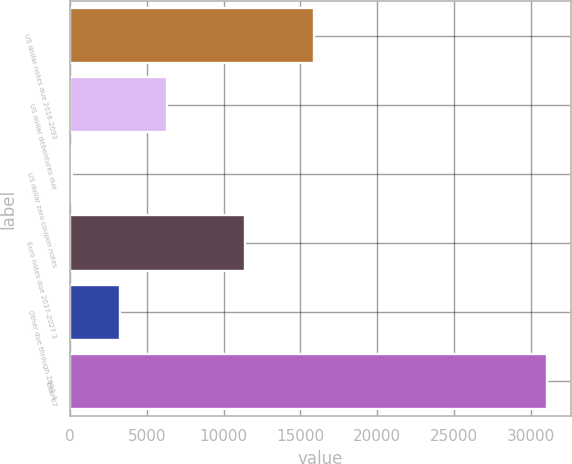Convert chart to OTSL. <chart><loc_0><loc_0><loc_500><loc_500><bar_chart><fcel>US dollar notes due 2016-2093<fcel>US dollar debentures due<fcel>US dollar zero coupon notes<fcel>Euro notes due 2017-2027 3<fcel>Other due through 2098 4<fcel>Total 67<nl><fcel>15899<fcel>6335.2<fcel>148<fcel>11364<fcel>3241.6<fcel>31084<nl></chart> 